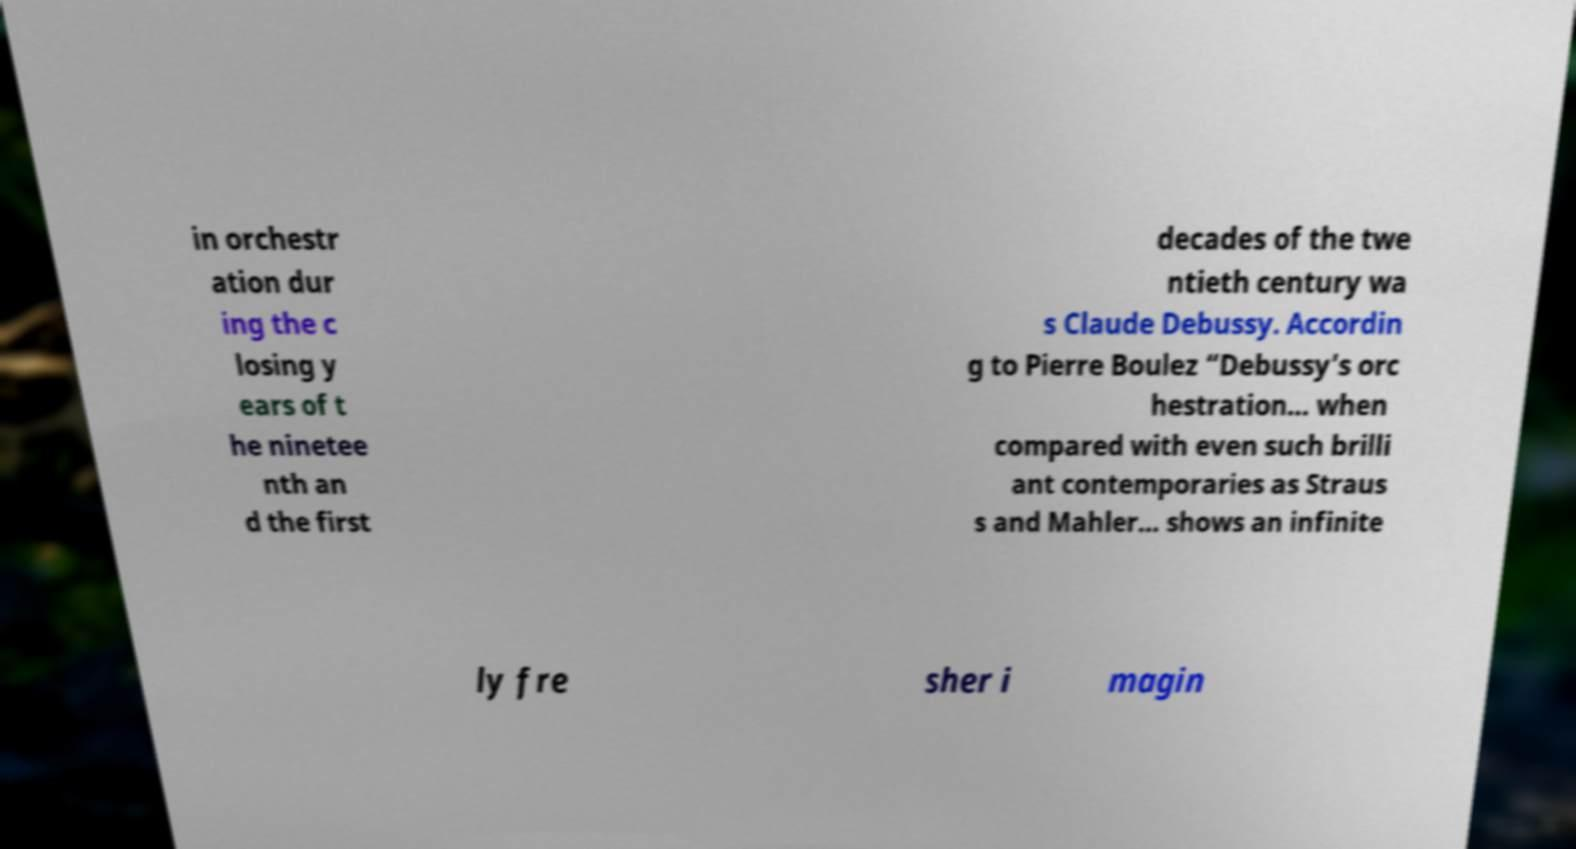There's text embedded in this image that I need extracted. Can you transcribe it verbatim? in orchestr ation dur ing the c losing y ears of t he ninetee nth an d the first decades of the twe ntieth century wa s Claude Debussy. Accordin g to Pierre Boulez “Debussy’s orc hestration… when compared with even such brilli ant contemporaries as Straus s and Mahler… shows an infinite ly fre sher i magin 